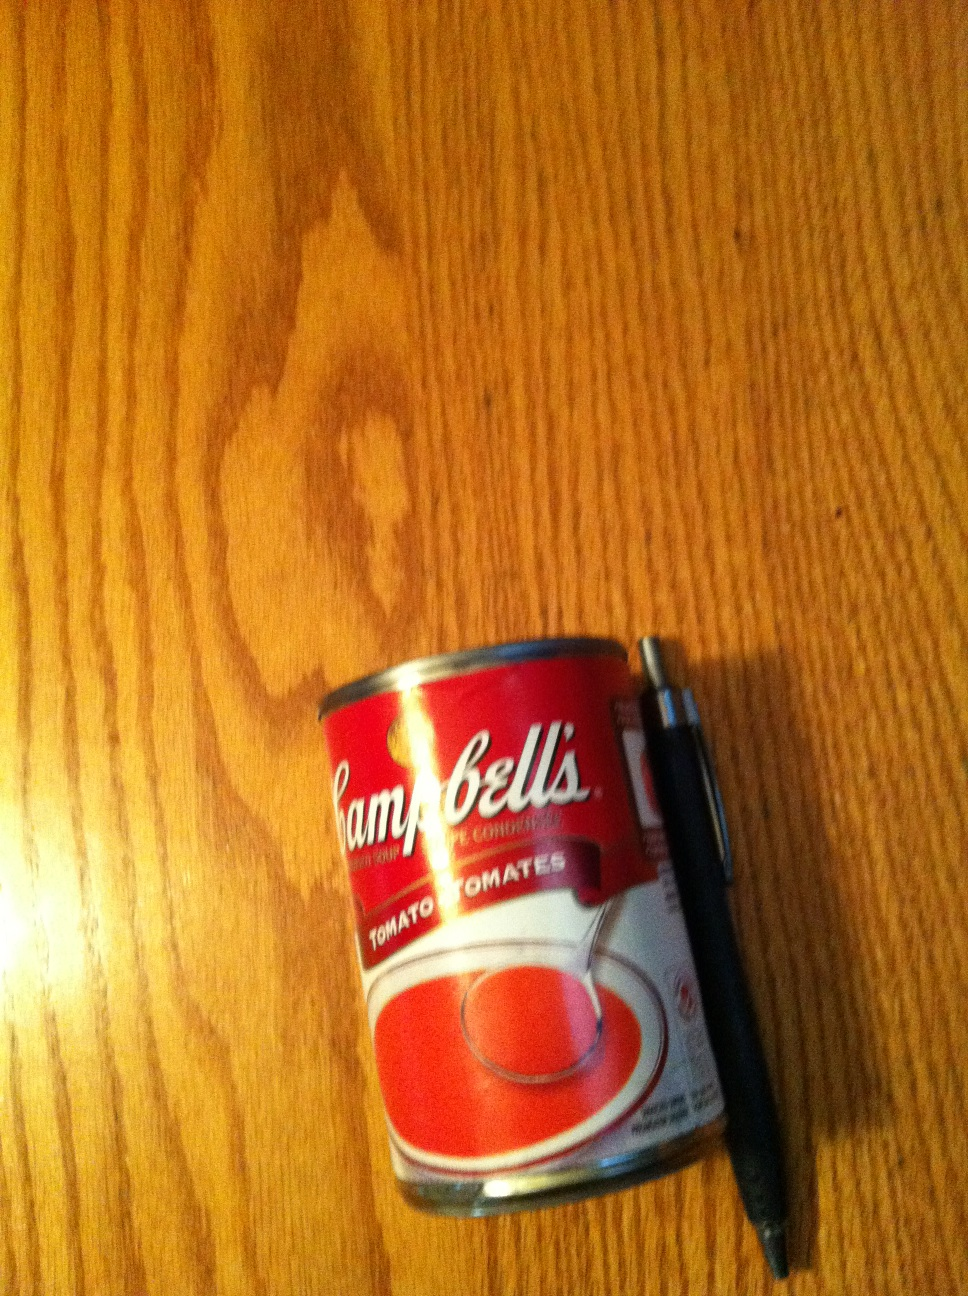What is this? from Vizwiz This is a can of Campbell's condensed tomato soup, as indicated by the distinctive red and white label with the brand name visible on the can. 